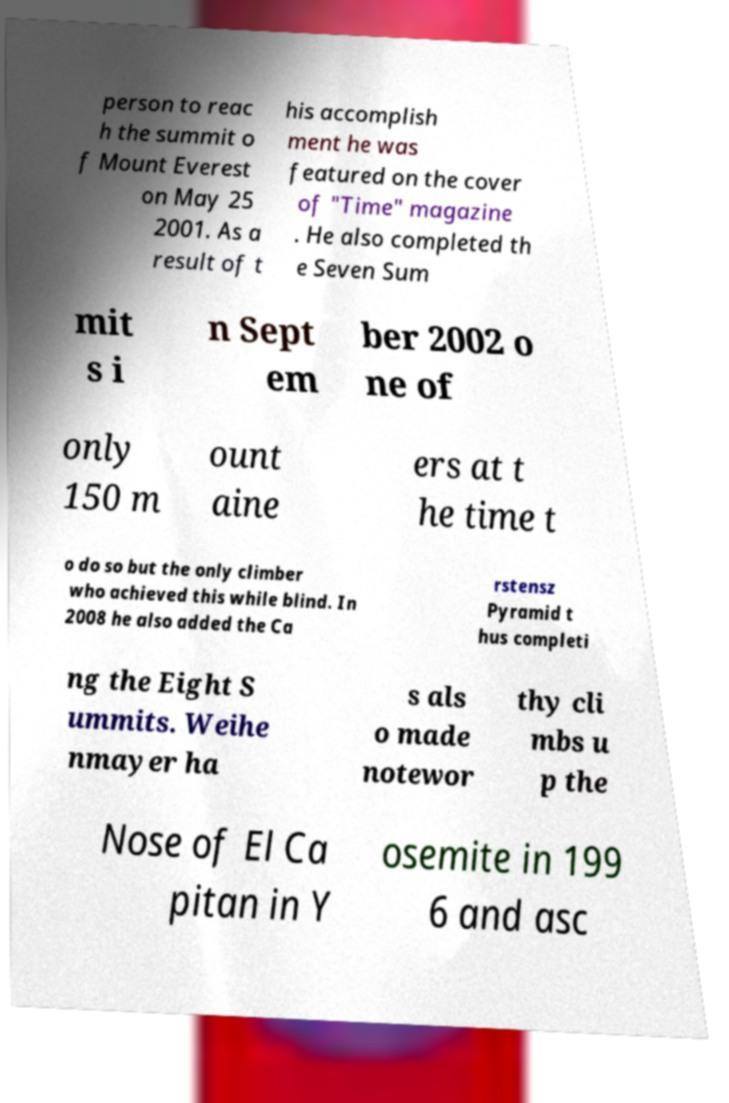Could you extract and type out the text from this image? person to reac h the summit o f Mount Everest on May 25 2001. As a result of t his accomplish ment he was featured on the cover of "Time" magazine . He also completed th e Seven Sum mit s i n Sept em ber 2002 o ne of only 150 m ount aine ers at t he time t o do so but the only climber who achieved this while blind. In 2008 he also added the Ca rstensz Pyramid t hus completi ng the Eight S ummits. Weihe nmayer ha s als o made notewor thy cli mbs u p the Nose of El Ca pitan in Y osemite in 199 6 and asc 